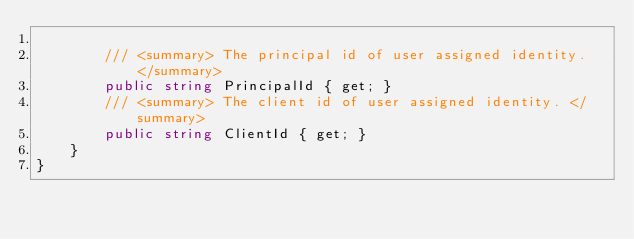Convert code to text. <code><loc_0><loc_0><loc_500><loc_500><_C#_>
        /// <summary> The principal id of user assigned identity. </summary>
        public string PrincipalId { get; }
        /// <summary> The client id of user assigned identity. </summary>
        public string ClientId { get; }
    }
}
</code> 